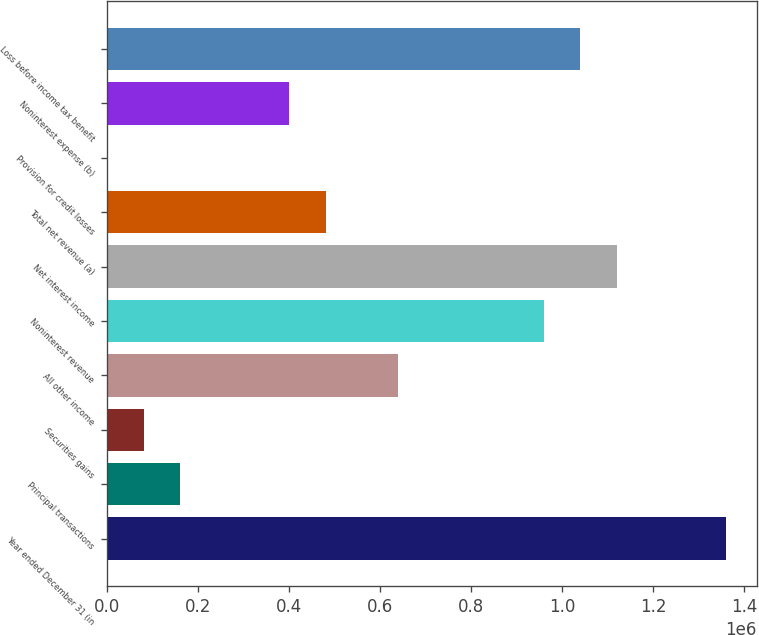Convert chart to OTSL. <chart><loc_0><loc_0><loc_500><loc_500><bar_chart><fcel>Year ended December 31 (in<fcel>Principal transactions<fcel>Securities gains<fcel>All other income<fcel>Noninterest revenue<fcel>Net interest income<fcel>Total net revenue (a)<fcel>Provision for credit losses<fcel>Noninterest expense (b)<fcel>Loss before income tax benefit<nl><fcel>1.35902e+06<fcel>159888<fcel>79946.2<fcel>639542<fcel>959310<fcel>1.11919e+06<fcel>479657<fcel>4<fcel>399715<fcel>1.03925e+06<nl></chart> 